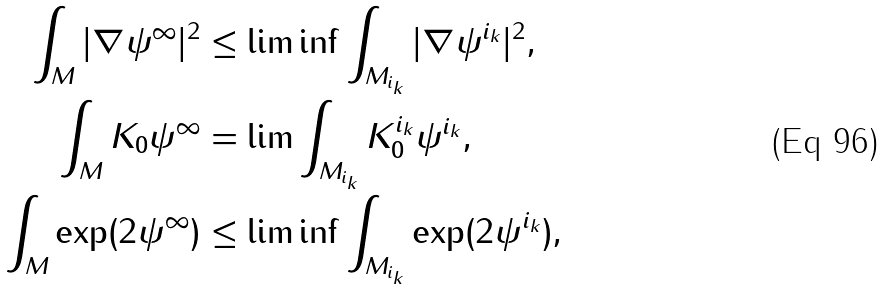Convert formula to latex. <formula><loc_0><loc_0><loc_500><loc_500>\int _ { M } | \nabla \psi ^ { \infty } | ^ { 2 } & \leq \liminf \int _ { M _ { i _ { k } } } | \nabla \psi ^ { i _ { k } } | ^ { 2 } , \\ \int _ { M } K _ { 0 } \psi ^ { \infty } & = \lim \int _ { M _ { i _ { k } } } K _ { 0 } ^ { i _ { k } } \psi ^ { i _ { k } } , \\ \int _ { M } \exp ( { 2 \psi ^ { \infty } } ) & \leq \liminf \int _ { M _ { i _ { k } } } \exp ( { 2 \psi ^ { i _ { k } } } ) ,</formula> 